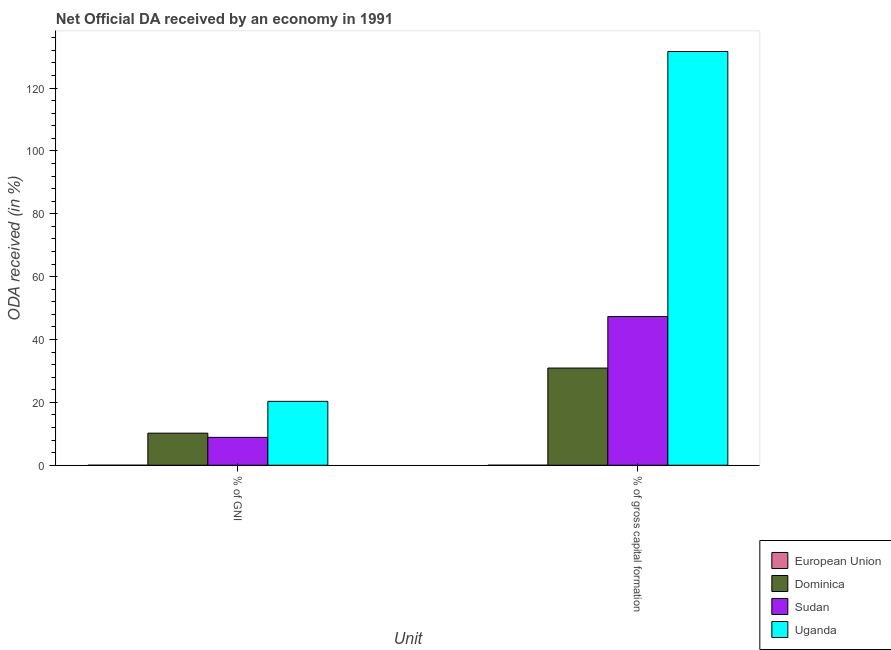Are the number of bars per tick equal to the number of legend labels?
Your response must be concise. Yes. Are the number of bars on each tick of the X-axis equal?
Make the answer very short. Yes. How many bars are there on the 1st tick from the right?
Offer a terse response. 4. What is the label of the 2nd group of bars from the left?
Offer a very short reply. % of gross capital formation. What is the oda received as percentage of gross capital formation in Uganda?
Provide a short and direct response. 131.62. Across all countries, what is the maximum oda received as percentage of gross capital formation?
Offer a terse response. 131.62. Across all countries, what is the minimum oda received as percentage of gni?
Ensure brevity in your answer.  0. In which country was the oda received as percentage of gni maximum?
Your answer should be compact. Uganda. What is the total oda received as percentage of gross capital formation in the graph?
Your response must be concise. 209.83. What is the difference between the oda received as percentage of gni in Uganda and that in Dominica?
Your answer should be very brief. 10.12. What is the difference between the oda received as percentage of gni in Sudan and the oda received as percentage of gross capital formation in Uganda?
Keep it short and to the point. -122.75. What is the average oda received as percentage of gni per country?
Make the answer very short. 9.85. What is the difference between the oda received as percentage of gross capital formation and oda received as percentage of gni in Sudan?
Offer a very short reply. 38.43. In how many countries, is the oda received as percentage of gni greater than 120 %?
Provide a succinct answer. 0. What is the ratio of the oda received as percentage of gni in Dominica to that in Uganda?
Offer a terse response. 0.5. Is the oda received as percentage of gni in European Union less than that in Sudan?
Provide a short and direct response. Yes. In how many countries, is the oda received as percentage of gross capital formation greater than the average oda received as percentage of gross capital formation taken over all countries?
Keep it short and to the point. 1. How many bars are there?
Provide a succinct answer. 8. Are all the bars in the graph horizontal?
Your answer should be very brief. No. Are the values on the major ticks of Y-axis written in scientific E-notation?
Your answer should be very brief. No. How many legend labels are there?
Provide a short and direct response. 4. What is the title of the graph?
Your response must be concise. Net Official DA received by an economy in 1991. Does "Finland" appear as one of the legend labels in the graph?
Give a very brief answer. No. What is the label or title of the X-axis?
Offer a terse response. Unit. What is the label or title of the Y-axis?
Ensure brevity in your answer.  ODA received (in %). What is the ODA received (in %) of European Union in % of GNI?
Provide a succinct answer. 0. What is the ODA received (in %) in Dominica in % of GNI?
Provide a succinct answer. 10.2. What is the ODA received (in %) in Sudan in % of GNI?
Provide a succinct answer. 8.87. What is the ODA received (in %) of Uganda in % of GNI?
Your answer should be compact. 20.32. What is the ODA received (in %) of European Union in % of gross capital formation?
Offer a terse response. 0. What is the ODA received (in %) of Dominica in % of gross capital formation?
Make the answer very short. 30.92. What is the ODA received (in %) of Sudan in % of gross capital formation?
Make the answer very short. 47.3. What is the ODA received (in %) in Uganda in % of gross capital formation?
Offer a terse response. 131.62. Across all Unit, what is the maximum ODA received (in %) in European Union?
Provide a succinct answer. 0. Across all Unit, what is the maximum ODA received (in %) of Dominica?
Give a very brief answer. 30.92. Across all Unit, what is the maximum ODA received (in %) of Sudan?
Offer a very short reply. 47.3. Across all Unit, what is the maximum ODA received (in %) of Uganda?
Provide a short and direct response. 131.62. Across all Unit, what is the minimum ODA received (in %) in European Union?
Offer a very short reply. 0. Across all Unit, what is the minimum ODA received (in %) in Dominica?
Keep it short and to the point. 10.2. Across all Unit, what is the minimum ODA received (in %) in Sudan?
Make the answer very short. 8.87. Across all Unit, what is the minimum ODA received (in %) of Uganda?
Provide a succinct answer. 20.32. What is the total ODA received (in %) in European Union in the graph?
Your answer should be compact. 0. What is the total ODA received (in %) in Dominica in the graph?
Ensure brevity in your answer.  41.12. What is the total ODA received (in %) in Sudan in the graph?
Your answer should be very brief. 56.16. What is the total ODA received (in %) of Uganda in the graph?
Provide a short and direct response. 151.94. What is the difference between the ODA received (in %) of European Union in % of GNI and that in % of gross capital formation?
Make the answer very short. -0. What is the difference between the ODA received (in %) of Dominica in % of GNI and that in % of gross capital formation?
Your response must be concise. -20.71. What is the difference between the ODA received (in %) of Sudan in % of GNI and that in % of gross capital formation?
Your response must be concise. -38.43. What is the difference between the ODA received (in %) in Uganda in % of GNI and that in % of gross capital formation?
Provide a short and direct response. -111.29. What is the difference between the ODA received (in %) in European Union in % of GNI and the ODA received (in %) in Dominica in % of gross capital formation?
Your answer should be compact. -30.91. What is the difference between the ODA received (in %) of European Union in % of GNI and the ODA received (in %) of Sudan in % of gross capital formation?
Provide a succinct answer. -47.3. What is the difference between the ODA received (in %) of European Union in % of GNI and the ODA received (in %) of Uganda in % of gross capital formation?
Give a very brief answer. -131.62. What is the difference between the ODA received (in %) in Dominica in % of GNI and the ODA received (in %) in Sudan in % of gross capital formation?
Offer a very short reply. -37.09. What is the difference between the ODA received (in %) of Dominica in % of GNI and the ODA received (in %) of Uganda in % of gross capital formation?
Provide a short and direct response. -121.41. What is the difference between the ODA received (in %) in Sudan in % of GNI and the ODA received (in %) in Uganda in % of gross capital formation?
Your answer should be compact. -122.75. What is the average ODA received (in %) of European Union per Unit?
Provide a short and direct response. 0. What is the average ODA received (in %) in Dominica per Unit?
Offer a terse response. 20.56. What is the average ODA received (in %) of Sudan per Unit?
Offer a very short reply. 28.08. What is the average ODA received (in %) in Uganda per Unit?
Your answer should be very brief. 75.97. What is the difference between the ODA received (in %) in European Union and ODA received (in %) in Dominica in % of GNI?
Offer a very short reply. -10.2. What is the difference between the ODA received (in %) of European Union and ODA received (in %) of Sudan in % of GNI?
Provide a succinct answer. -8.87. What is the difference between the ODA received (in %) in European Union and ODA received (in %) in Uganda in % of GNI?
Give a very brief answer. -20.32. What is the difference between the ODA received (in %) in Dominica and ODA received (in %) in Sudan in % of GNI?
Keep it short and to the point. 1.34. What is the difference between the ODA received (in %) of Dominica and ODA received (in %) of Uganda in % of GNI?
Ensure brevity in your answer.  -10.12. What is the difference between the ODA received (in %) of Sudan and ODA received (in %) of Uganda in % of GNI?
Give a very brief answer. -11.46. What is the difference between the ODA received (in %) of European Union and ODA received (in %) of Dominica in % of gross capital formation?
Provide a succinct answer. -30.91. What is the difference between the ODA received (in %) of European Union and ODA received (in %) of Sudan in % of gross capital formation?
Make the answer very short. -47.29. What is the difference between the ODA received (in %) of European Union and ODA received (in %) of Uganda in % of gross capital formation?
Make the answer very short. -131.61. What is the difference between the ODA received (in %) of Dominica and ODA received (in %) of Sudan in % of gross capital formation?
Provide a short and direct response. -16.38. What is the difference between the ODA received (in %) of Dominica and ODA received (in %) of Uganda in % of gross capital formation?
Offer a very short reply. -100.7. What is the difference between the ODA received (in %) of Sudan and ODA received (in %) of Uganda in % of gross capital formation?
Offer a terse response. -84.32. What is the ratio of the ODA received (in %) in European Union in % of GNI to that in % of gross capital formation?
Give a very brief answer. 0.23. What is the ratio of the ODA received (in %) in Dominica in % of GNI to that in % of gross capital formation?
Make the answer very short. 0.33. What is the ratio of the ODA received (in %) in Sudan in % of GNI to that in % of gross capital formation?
Make the answer very short. 0.19. What is the ratio of the ODA received (in %) in Uganda in % of GNI to that in % of gross capital formation?
Keep it short and to the point. 0.15. What is the difference between the highest and the second highest ODA received (in %) in European Union?
Provide a succinct answer. 0. What is the difference between the highest and the second highest ODA received (in %) of Dominica?
Offer a very short reply. 20.71. What is the difference between the highest and the second highest ODA received (in %) in Sudan?
Keep it short and to the point. 38.43. What is the difference between the highest and the second highest ODA received (in %) in Uganda?
Offer a terse response. 111.29. What is the difference between the highest and the lowest ODA received (in %) in European Union?
Provide a short and direct response. 0. What is the difference between the highest and the lowest ODA received (in %) in Dominica?
Ensure brevity in your answer.  20.71. What is the difference between the highest and the lowest ODA received (in %) of Sudan?
Your response must be concise. 38.43. What is the difference between the highest and the lowest ODA received (in %) in Uganda?
Keep it short and to the point. 111.29. 